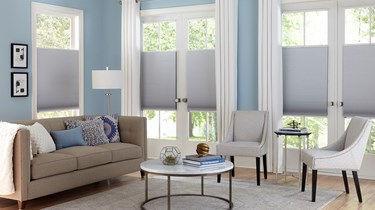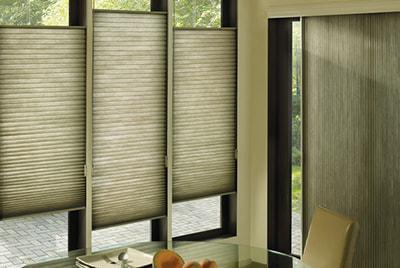The first image is the image on the left, the second image is the image on the right. Analyze the images presented: Is the assertion "The left and right image contains a total of seven blinds." valid? Answer yes or no. No. 